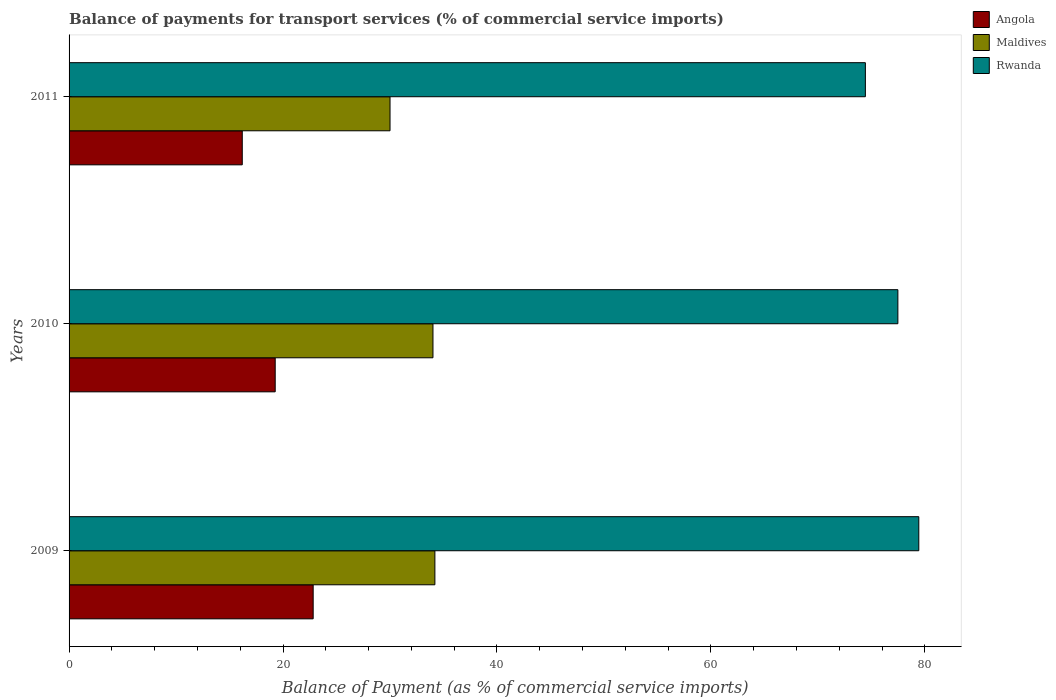How many different coloured bars are there?
Give a very brief answer. 3. How many bars are there on the 3rd tick from the top?
Your answer should be compact. 3. In how many cases, is the number of bars for a given year not equal to the number of legend labels?
Your answer should be very brief. 0. What is the balance of payments for transport services in Maldives in 2010?
Your answer should be compact. 34.02. Across all years, what is the maximum balance of payments for transport services in Rwanda?
Your response must be concise. 79.44. Across all years, what is the minimum balance of payments for transport services in Rwanda?
Provide a succinct answer. 74.44. In which year was the balance of payments for transport services in Rwanda maximum?
Ensure brevity in your answer.  2009. In which year was the balance of payments for transport services in Rwanda minimum?
Offer a very short reply. 2011. What is the total balance of payments for transport services in Angola in the graph?
Keep it short and to the point. 58.28. What is the difference between the balance of payments for transport services in Rwanda in 2009 and that in 2011?
Provide a short and direct response. 4.99. What is the difference between the balance of payments for transport services in Rwanda in 2009 and the balance of payments for transport services in Maldives in 2011?
Your response must be concise. 49.43. What is the average balance of payments for transport services in Maldives per year?
Provide a succinct answer. 32.74. In the year 2011, what is the difference between the balance of payments for transport services in Angola and balance of payments for transport services in Maldives?
Make the answer very short. -13.81. In how many years, is the balance of payments for transport services in Angola greater than 8 %?
Keep it short and to the point. 3. What is the ratio of the balance of payments for transport services in Angola in 2009 to that in 2010?
Offer a terse response. 1.18. What is the difference between the highest and the second highest balance of payments for transport services in Angola?
Your answer should be very brief. 3.55. What is the difference between the highest and the lowest balance of payments for transport services in Rwanda?
Offer a terse response. 4.99. What does the 2nd bar from the top in 2009 represents?
Make the answer very short. Maldives. What does the 2nd bar from the bottom in 2009 represents?
Provide a succinct answer. Maldives. Are all the bars in the graph horizontal?
Provide a short and direct response. Yes. How many years are there in the graph?
Your answer should be very brief. 3. Does the graph contain grids?
Offer a terse response. No. Where does the legend appear in the graph?
Ensure brevity in your answer.  Top right. How are the legend labels stacked?
Provide a short and direct response. Vertical. What is the title of the graph?
Your answer should be very brief. Balance of payments for transport services (% of commercial service imports). What is the label or title of the X-axis?
Make the answer very short. Balance of Payment (as % of commercial service imports). What is the label or title of the Y-axis?
Provide a short and direct response. Years. What is the Balance of Payment (as % of commercial service imports) of Angola in 2009?
Provide a short and direct response. 22.82. What is the Balance of Payment (as % of commercial service imports) of Maldives in 2009?
Keep it short and to the point. 34.2. What is the Balance of Payment (as % of commercial service imports) in Rwanda in 2009?
Your response must be concise. 79.44. What is the Balance of Payment (as % of commercial service imports) of Angola in 2010?
Provide a succinct answer. 19.27. What is the Balance of Payment (as % of commercial service imports) in Maldives in 2010?
Keep it short and to the point. 34.02. What is the Balance of Payment (as % of commercial service imports) in Rwanda in 2010?
Give a very brief answer. 77.48. What is the Balance of Payment (as % of commercial service imports) in Angola in 2011?
Your response must be concise. 16.19. What is the Balance of Payment (as % of commercial service imports) in Maldives in 2011?
Offer a very short reply. 30. What is the Balance of Payment (as % of commercial service imports) of Rwanda in 2011?
Your answer should be very brief. 74.44. Across all years, what is the maximum Balance of Payment (as % of commercial service imports) of Angola?
Your answer should be compact. 22.82. Across all years, what is the maximum Balance of Payment (as % of commercial service imports) of Maldives?
Provide a short and direct response. 34.2. Across all years, what is the maximum Balance of Payment (as % of commercial service imports) in Rwanda?
Offer a very short reply. 79.44. Across all years, what is the minimum Balance of Payment (as % of commercial service imports) of Angola?
Your response must be concise. 16.19. Across all years, what is the minimum Balance of Payment (as % of commercial service imports) in Maldives?
Your answer should be very brief. 30. Across all years, what is the minimum Balance of Payment (as % of commercial service imports) in Rwanda?
Make the answer very short. 74.44. What is the total Balance of Payment (as % of commercial service imports) of Angola in the graph?
Keep it short and to the point. 58.28. What is the total Balance of Payment (as % of commercial service imports) of Maldives in the graph?
Provide a succinct answer. 98.22. What is the total Balance of Payment (as % of commercial service imports) in Rwanda in the graph?
Provide a succinct answer. 231.36. What is the difference between the Balance of Payment (as % of commercial service imports) of Angola in 2009 and that in 2010?
Ensure brevity in your answer.  3.55. What is the difference between the Balance of Payment (as % of commercial service imports) in Maldives in 2009 and that in 2010?
Ensure brevity in your answer.  0.18. What is the difference between the Balance of Payment (as % of commercial service imports) of Rwanda in 2009 and that in 2010?
Keep it short and to the point. 1.96. What is the difference between the Balance of Payment (as % of commercial service imports) of Angola in 2009 and that in 2011?
Your response must be concise. 6.63. What is the difference between the Balance of Payment (as % of commercial service imports) in Maldives in 2009 and that in 2011?
Provide a succinct answer. 4.19. What is the difference between the Balance of Payment (as % of commercial service imports) of Rwanda in 2009 and that in 2011?
Provide a short and direct response. 4.99. What is the difference between the Balance of Payment (as % of commercial service imports) of Angola in 2010 and that in 2011?
Your answer should be compact. 3.08. What is the difference between the Balance of Payment (as % of commercial service imports) of Maldives in 2010 and that in 2011?
Offer a very short reply. 4.01. What is the difference between the Balance of Payment (as % of commercial service imports) in Rwanda in 2010 and that in 2011?
Provide a succinct answer. 3.04. What is the difference between the Balance of Payment (as % of commercial service imports) in Angola in 2009 and the Balance of Payment (as % of commercial service imports) in Maldives in 2010?
Your response must be concise. -11.2. What is the difference between the Balance of Payment (as % of commercial service imports) of Angola in 2009 and the Balance of Payment (as % of commercial service imports) of Rwanda in 2010?
Make the answer very short. -54.66. What is the difference between the Balance of Payment (as % of commercial service imports) of Maldives in 2009 and the Balance of Payment (as % of commercial service imports) of Rwanda in 2010?
Keep it short and to the point. -43.28. What is the difference between the Balance of Payment (as % of commercial service imports) in Angola in 2009 and the Balance of Payment (as % of commercial service imports) in Maldives in 2011?
Offer a terse response. -7.19. What is the difference between the Balance of Payment (as % of commercial service imports) of Angola in 2009 and the Balance of Payment (as % of commercial service imports) of Rwanda in 2011?
Provide a succinct answer. -51.62. What is the difference between the Balance of Payment (as % of commercial service imports) in Maldives in 2009 and the Balance of Payment (as % of commercial service imports) in Rwanda in 2011?
Ensure brevity in your answer.  -40.24. What is the difference between the Balance of Payment (as % of commercial service imports) of Angola in 2010 and the Balance of Payment (as % of commercial service imports) of Maldives in 2011?
Your answer should be compact. -10.73. What is the difference between the Balance of Payment (as % of commercial service imports) of Angola in 2010 and the Balance of Payment (as % of commercial service imports) of Rwanda in 2011?
Provide a succinct answer. -55.17. What is the difference between the Balance of Payment (as % of commercial service imports) of Maldives in 2010 and the Balance of Payment (as % of commercial service imports) of Rwanda in 2011?
Your answer should be compact. -40.42. What is the average Balance of Payment (as % of commercial service imports) in Angola per year?
Provide a short and direct response. 19.43. What is the average Balance of Payment (as % of commercial service imports) of Maldives per year?
Provide a short and direct response. 32.74. What is the average Balance of Payment (as % of commercial service imports) in Rwanda per year?
Ensure brevity in your answer.  77.12. In the year 2009, what is the difference between the Balance of Payment (as % of commercial service imports) of Angola and Balance of Payment (as % of commercial service imports) of Maldives?
Provide a succinct answer. -11.38. In the year 2009, what is the difference between the Balance of Payment (as % of commercial service imports) of Angola and Balance of Payment (as % of commercial service imports) of Rwanda?
Offer a terse response. -56.62. In the year 2009, what is the difference between the Balance of Payment (as % of commercial service imports) in Maldives and Balance of Payment (as % of commercial service imports) in Rwanda?
Provide a short and direct response. -45.24. In the year 2010, what is the difference between the Balance of Payment (as % of commercial service imports) of Angola and Balance of Payment (as % of commercial service imports) of Maldives?
Provide a short and direct response. -14.75. In the year 2010, what is the difference between the Balance of Payment (as % of commercial service imports) of Angola and Balance of Payment (as % of commercial service imports) of Rwanda?
Offer a terse response. -58.21. In the year 2010, what is the difference between the Balance of Payment (as % of commercial service imports) of Maldives and Balance of Payment (as % of commercial service imports) of Rwanda?
Make the answer very short. -43.46. In the year 2011, what is the difference between the Balance of Payment (as % of commercial service imports) of Angola and Balance of Payment (as % of commercial service imports) of Maldives?
Provide a short and direct response. -13.81. In the year 2011, what is the difference between the Balance of Payment (as % of commercial service imports) of Angola and Balance of Payment (as % of commercial service imports) of Rwanda?
Make the answer very short. -58.25. In the year 2011, what is the difference between the Balance of Payment (as % of commercial service imports) in Maldives and Balance of Payment (as % of commercial service imports) in Rwanda?
Provide a short and direct response. -44.44. What is the ratio of the Balance of Payment (as % of commercial service imports) of Angola in 2009 to that in 2010?
Offer a terse response. 1.18. What is the ratio of the Balance of Payment (as % of commercial service imports) in Maldives in 2009 to that in 2010?
Keep it short and to the point. 1.01. What is the ratio of the Balance of Payment (as % of commercial service imports) of Rwanda in 2009 to that in 2010?
Your answer should be compact. 1.03. What is the ratio of the Balance of Payment (as % of commercial service imports) of Angola in 2009 to that in 2011?
Ensure brevity in your answer.  1.41. What is the ratio of the Balance of Payment (as % of commercial service imports) of Maldives in 2009 to that in 2011?
Your answer should be very brief. 1.14. What is the ratio of the Balance of Payment (as % of commercial service imports) of Rwanda in 2009 to that in 2011?
Give a very brief answer. 1.07. What is the ratio of the Balance of Payment (as % of commercial service imports) in Angola in 2010 to that in 2011?
Make the answer very short. 1.19. What is the ratio of the Balance of Payment (as % of commercial service imports) of Maldives in 2010 to that in 2011?
Offer a very short reply. 1.13. What is the ratio of the Balance of Payment (as % of commercial service imports) in Rwanda in 2010 to that in 2011?
Your answer should be compact. 1.04. What is the difference between the highest and the second highest Balance of Payment (as % of commercial service imports) of Angola?
Provide a succinct answer. 3.55. What is the difference between the highest and the second highest Balance of Payment (as % of commercial service imports) of Maldives?
Ensure brevity in your answer.  0.18. What is the difference between the highest and the second highest Balance of Payment (as % of commercial service imports) in Rwanda?
Your answer should be compact. 1.96. What is the difference between the highest and the lowest Balance of Payment (as % of commercial service imports) of Angola?
Make the answer very short. 6.63. What is the difference between the highest and the lowest Balance of Payment (as % of commercial service imports) in Maldives?
Provide a succinct answer. 4.19. What is the difference between the highest and the lowest Balance of Payment (as % of commercial service imports) of Rwanda?
Provide a succinct answer. 4.99. 